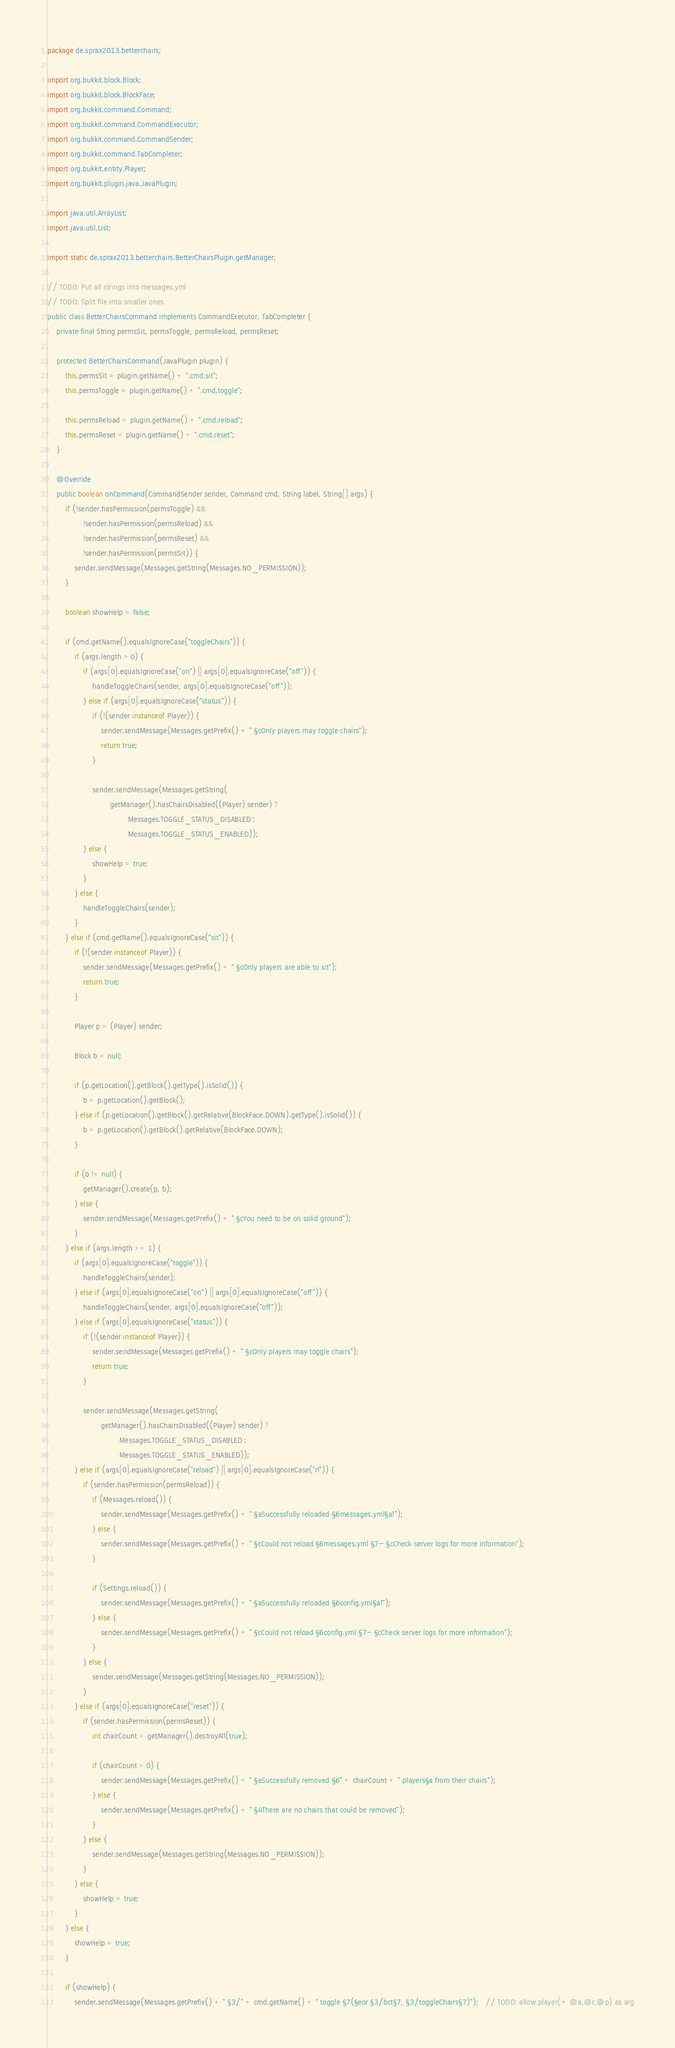Convert code to text. <code><loc_0><loc_0><loc_500><loc_500><_Java_>package de.sprax2013.betterchairs;

import org.bukkit.block.Block;
import org.bukkit.block.BlockFace;
import org.bukkit.command.Command;
import org.bukkit.command.CommandExecutor;
import org.bukkit.command.CommandSender;
import org.bukkit.command.TabCompleter;
import org.bukkit.entity.Player;
import org.bukkit.plugin.java.JavaPlugin;

import java.util.ArrayList;
import java.util.List;

import static de.sprax2013.betterchairs.BetterChairsPlugin.getManager;

// TODO: Put all strings into messages.yml
// TODO: Split file into smaller ones
public class BetterChairsCommand implements CommandExecutor, TabCompleter {
    private final String permsSit, permsToggle, permsReload, permsReset;

    protected BetterChairsCommand(JavaPlugin plugin) {
        this.permsSit = plugin.getName() + ".cmd.sit";
        this.permsToggle = plugin.getName() + ".cmd.toggle";

        this.permsReload = plugin.getName() + ".cmd.reload";
        this.permsReset = plugin.getName() + ".cmd.reset";
    }

    @Override
    public boolean onCommand(CommandSender sender, Command cmd, String label, String[] args) {
        if (!sender.hasPermission(permsToggle) &&
                !sender.hasPermission(permsReload) &&
                !sender.hasPermission(permsReset) &&
                !sender.hasPermission(permsSit)) {
            sender.sendMessage(Messages.getString(Messages.NO_PERMISSION));
        }

        boolean showHelp = false;

        if (cmd.getName().equalsIgnoreCase("toggleChairs")) {
            if (args.length > 0) {
                if (args[0].equalsIgnoreCase("on") || args[0].equalsIgnoreCase("off")) {
                    handleToggleChairs(sender, args[0].equalsIgnoreCase("off"));
                } else if (args[0].equalsIgnoreCase("status")) {
                    if (!(sender instanceof Player)) {
                        sender.sendMessage(Messages.getPrefix() + " §cOnly players may toggle chairs");
                        return true;
                    }

                    sender.sendMessage(Messages.getString(
                            getManager().hasChairsDisabled((Player) sender) ?
                                    Messages.TOGGLE_STATUS_DISABLED :
                                    Messages.TOGGLE_STATUS_ENABLED));
                } else {
                    showHelp = true;
                }
            } else {
                handleToggleChairs(sender);
            }
        } else if (cmd.getName().equalsIgnoreCase("sit")) {
            if (!(sender instanceof Player)) {
                sender.sendMessage(Messages.getPrefix() + " §cOnly players are able to sit");
                return true;
            }

            Player p = (Player) sender;

            Block b = null;

            if (p.getLocation().getBlock().getType().isSolid()) {
                b = p.getLocation().getBlock();
            } else if (p.getLocation().getBlock().getRelative(BlockFace.DOWN).getType().isSolid()) {
                b = p.getLocation().getBlock().getRelative(BlockFace.DOWN);
            }

            if (b != null) {
                getManager().create(p, b);
            } else {
                sender.sendMessage(Messages.getPrefix() + " §cYou need to be on solid ground");
            }
        } else if (args.length >= 1) {
            if (args[0].equalsIgnoreCase("toggle")) {
                handleToggleChairs(sender);
            } else if (args[0].equalsIgnoreCase("on") || args[0].equalsIgnoreCase("off")) {
                handleToggleChairs(sender, args[0].equalsIgnoreCase("off"));
            } else if (args[0].equalsIgnoreCase("status")) {
                if (!(sender instanceof Player)) {
                    sender.sendMessage(Messages.getPrefix() + " §cOnly players may toggle chairs");
                    return true;
                }

                sender.sendMessage(Messages.getString(
                        getManager().hasChairsDisabled((Player) sender) ?
                                Messages.TOGGLE_STATUS_DISABLED :
                                Messages.TOGGLE_STATUS_ENABLED));
            } else if (args[0].equalsIgnoreCase("reload") || args[0].equalsIgnoreCase("rl")) {
                if (sender.hasPermission(permsReload)) {
                    if (Messages.reload()) {
                        sender.sendMessage(Messages.getPrefix() + " §aSuccessfully reloaded §6messages.yml§a!");
                    } else {
                        sender.sendMessage(Messages.getPrefix() + " §cCould not reload §6messages.yml §7- §cCheck server logs for more information");
                    }

                    if (Settings.reload()) {
                        sender.sendMessage(Messages.getPrefix() + " §aSuccessfully reloaded §6config.yml§a!");
                    } else {
                        sender.sendMessage(Messages.getPrefix() + " §cCould not reload §6config.yml §7- §cCheck server logs for more information");
                    }
                } else {
                    sender.sendMessage(Messages.getString(Messages.NO_PERMISSION));
                }
            } else if (args[0].equalsIgnoreCase("reset")) {
                if (sender.hasPermission(permsReset)) {
                    int chairCount = getManager().destroyAll(true);

                    if (chairCount > 0) {
                        sender.sendMessage(Messages.getPrefix() + " §aSuccessfully removed §6" + chairCount + " players§a from their chairs");
                    } else {
                        sender.sendMessage(Messages.getPrefix() + " §4There are no chairs that could be removed");
                    }
                } else {
                    sender.sendMessage(Messages.getString(Messages.NO_PERMISSION));
                }
            } else {
                showHelp = true;
            }
        } else {
            showHelp = true;
        }

        if (showHelp) {
            sender.sendMessage(Messages.getPrefix() + " §3/" + cmd.getName() + " toggle §7(§eor §3/bct§7, §3/toggleChairs§7)");   // TODO: allow player(+ @a,@r,@p) as arg</code> 